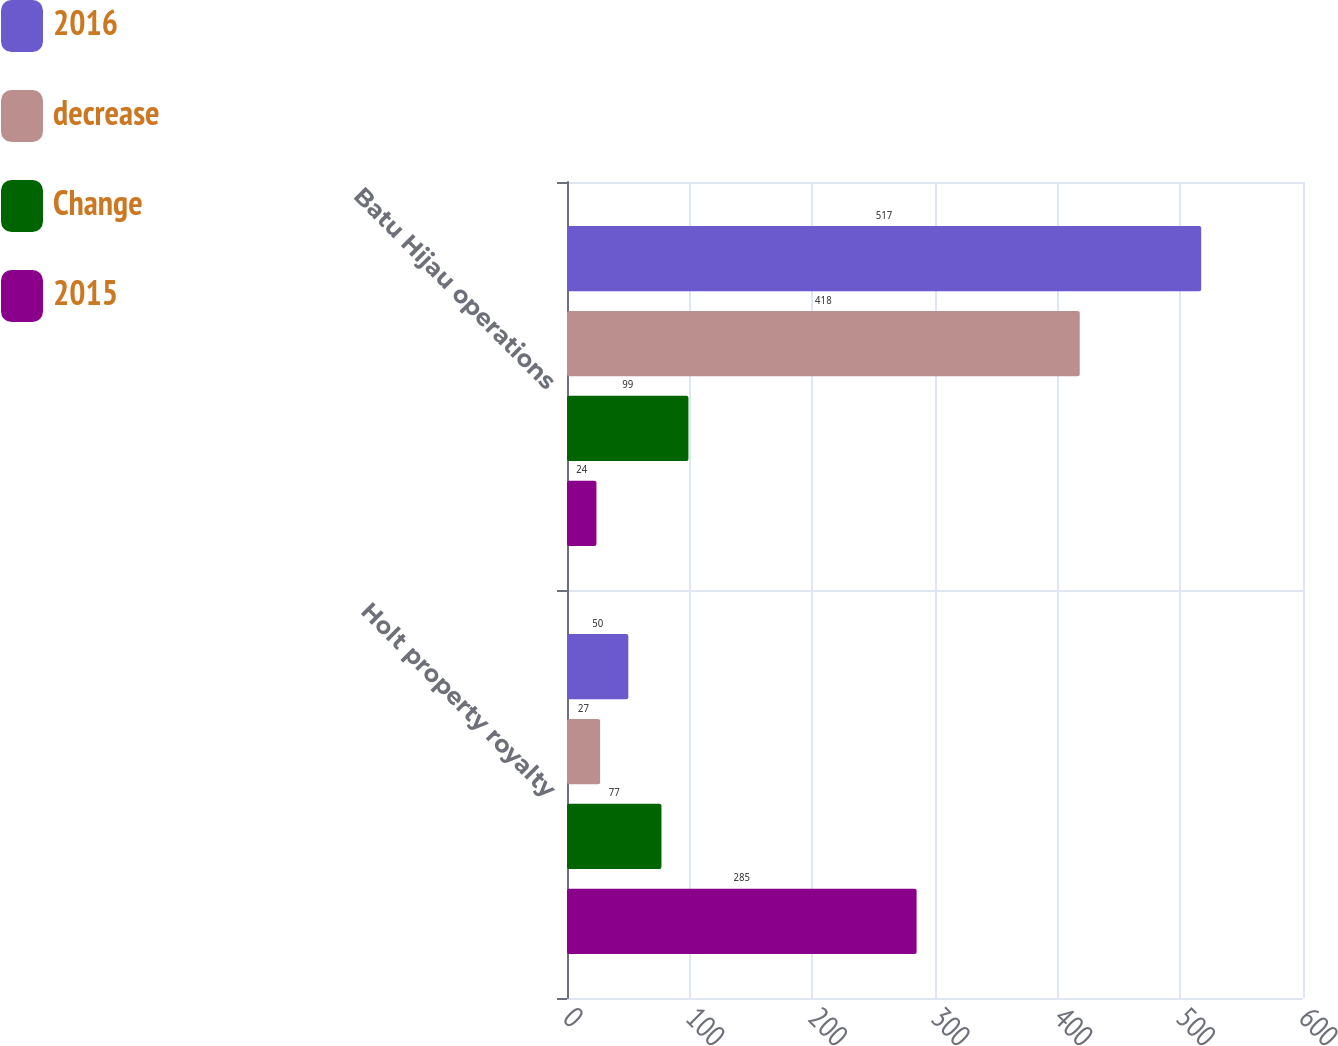Convert chart. <chart><loc_0><loc_0><loc_500><loc_500><stacked_bar_chart><ecel><fcel>Holt property royalty<fcel>Batu Hijau operations<nl><fcel>2016<fcel>50<fcel>517<nl><fcel>decrease<fcel>27<fcel>418<nl><fcel>Change<fcel>77<fcel>99<nl><fcel>2015<fcel>285<fcel>24<nl></chart> 